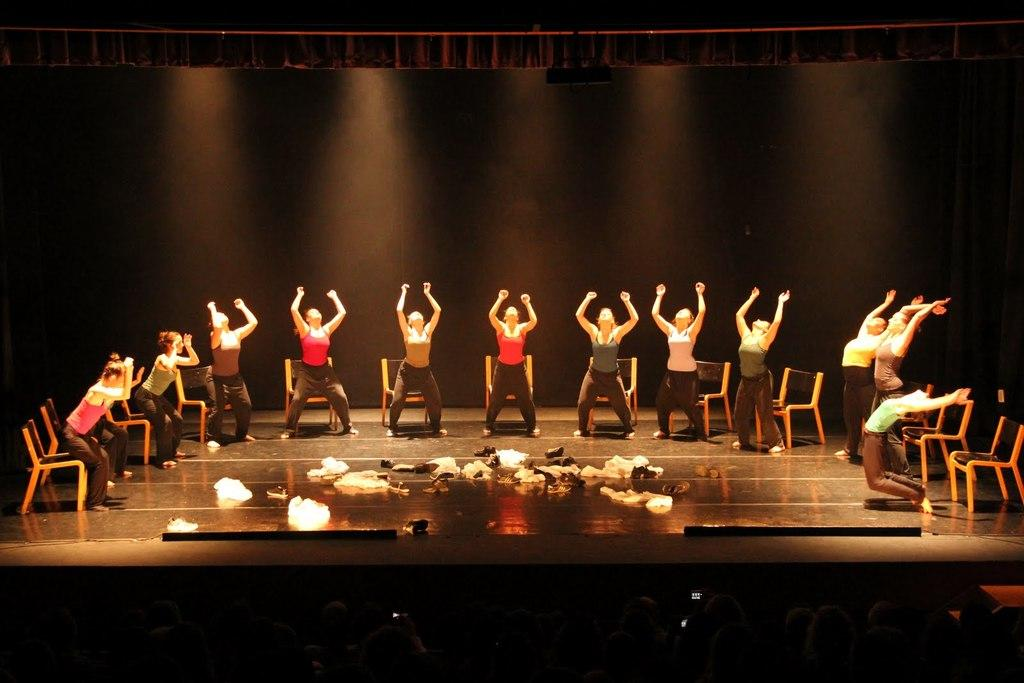Who or what can be seen in the image? There are people in the image. Can you describe the location of some people in the image? Some people are on a stage. What type of furniture is present in the image? There are chairs in the image. What else can be seen in the image besides people and chairs? There are other objects in the image. What is visible in the background of the image? There is a wall in the background of the image. What time of day is it in the image, and how does the destruction occur? The provided facts do not mention the time of day or any destruction in the image. The image features people, a stage, chairs, other objects, and a wall in the background. 